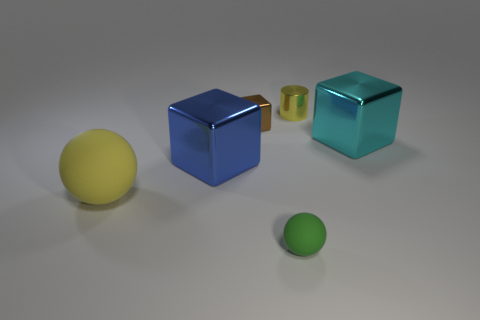Add 3 small blue spheres. How many objects exist? 9 Subtract all cylinders. How many objects are left? 5 Subtract all brown metallic cylinders. Subtract all green matte balls. How many objects are left? 5 Add 6 small cylinders. How many small cylinders are left? 7 Add 3 large purple blocks. How many large purple blocks exist? 3 Subtract 0 yellow blocks. How many objects are left? 6 